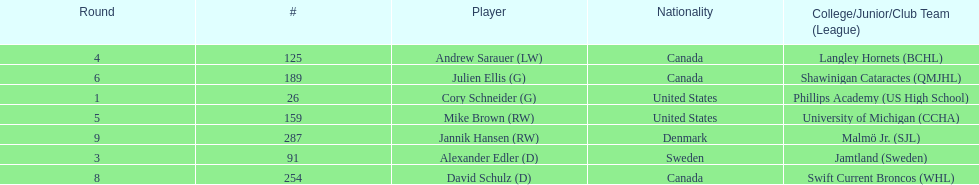What quantity of players have canada listed as their nationality? 3. 